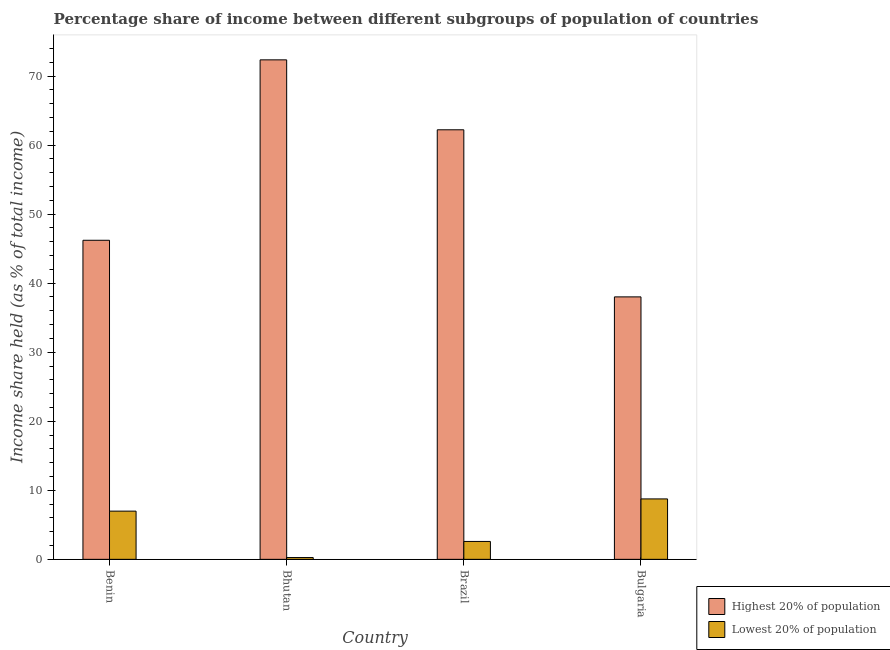Are the number of bars on each tick of the X-axis equal?
Provide a short and direct response. Yes. How many bars are there on the 1st tick from the left?
Ensure brevity in your answer.  2. How many bars are there on the 1st tick from the right?
Ensure brevity in your answer.  2. What is the income share held by lowest 20% of the population in Benin?
Keep it short and to the point. 6.98. Across all countries, what is the maximum income share held by highest 20% of the population?
Give a very brief answer. 72.34. Across all countries, what is the minimum income share held by lowest 20% of the population?
Offer a very short reply. 0.26. In which country was the income share held by highest 20% of the population maximum?
Provide a succinct answer. Bhutan. In which country was the income share held by lowest 20% of the population minimum?
Your response must be concise. Bhutan. What is the total income share held by lowest 20% of the population in the graph?
Give a very brief answer. 18.58. What is the difference between the income share held by highest 20% of the population in Bhutan and that in Brazil?
Provide a succinct answer. 10.13. What is the difference between the income share held by lowest 20% of the population in Bulgaria and the income share held by highest 20% of the population in Brazil?
Provide a short and direct response. -53.46. What is the average income share held by highest 20% of the population per country?
Your answer should be compact. 54.69. What is the difference between the income share held by lowest 20% of the population and income share held by highest 20% of the population in Bhutan?
Your answer should be very brief. -72.08. In how many countries, is the income share held by highest 20% of the population greater than 62 %?
Make the answer very short. 2. What is the ratio of the income share held by lowest 20% of the population in Brazil to that in Bulgaria?
Provide a succinct answer. 0.3. Is the difference between the income share held by lowest 20% of the population in Bhutan and Brazil greater than the difference between the income share held by highest 20% of the population in Bhutan and Brazil?
Keep it short and to the point. No. What is the difference between the highest and the second highest income share held by highest 20% of the population?
Your answer should be compact. 10.13. What is the difference between the highest and the lowest income share held by highest 20% of the population?
Your answer should be compact. 34.33. Is the sum of the income share held by lowest 20% of the population in Benin and Brazil greater than the maximum income share held by highest 20% of the population across all countries?
Ensure brevity in your answer.  No. What does the 2nd bar from the left in Bulgaria represents?
Provide a succinct answer. Lowest 20% of population. What does the 1st bar from the right in Bulgaria represents?
Provide a short and direct response. Lowest 20% of population. How many bars are there?
Provide a succinct answer. 8. Are all the bars in the graph horizontal?
Offer a very short reply. No. How many countries are there in the graph?
Offer a terse response. 4. What is the difference between two consecutive major ticks on the Y-axis?
Make the answer very short. 10. Does the graph contain any zero values?
Your answer should be compact. No. Does the graph contain grids?
Give a very brief answer. No. Where does the legend appear in the graph?
Your response must be concise. Bottom right. How many legend labels are there?
Offer a terse response. 2. What is the title of the graph?
Your answer should be very brief. Percentage share of income between different subgroups of population of countries. Does "Rural" appear as one of the legend labels in the graph?
Your answer should be very brief. No. What is the label or title of the X-axis?
Your response must be concise. Country. What is the label or title of the Y-axis?
Keep it short and to the point. Income share held (as % of total income). What is the Income share held (as % of total income) in Highest 20% of population in Benin?
Provide a succinct answer. 46.21. What is the Income share held (as % of total income) of Lowest 20% of population in Benin?
Your answer should be very brief. 6.98. What is the Income share held (as % of total income) of Highest 20% of population in Bhutan?
Your answer should be very brief. 72.34. What is the Income share held (as % of total income) in Lowest 20% of population in Bhutan?
Offer a very short reply. 0.26. What is the Income share held (as % of total income) in Highest 20% of population in Brazil?
Your response must be concise. 62.21. What is the Income share held (as % of total income) of Lowest 20% of population in Brazil?
Provide a short and direct response. 2.59. What is the Income share held (as % of total income) in Highest 20% of population in Bulgaria?
Keep it short and to the point. 38.01. What is the Income share held (as % of total income) of Lowest 20% of population in Bulgaria?
Offer a terse response. 8.75. Across all countries, what is the maximum Income share held (as % of total income) of Highest 20% of population?
Offer a terse response. 72.34. Across all countries, what is the maximum Income share held (as % of total income) of Lowest 20% of population?
Ensure brevity in your answer.  8.75. Across all countries, what is the minimum Income share held (as % of total income) in Highest 20% of population?
Your answer should be very brief. 38.01. Across all countries, what is the minimum Income share held (as % of total income) in Lowest 20% of population?
Your answer should be very brief. 0.26. What is the total Income share held (as % of total income) in Highest 20% of population in the graph?
Provide a short and direct response. 218.77. What is the total Income share held (as % of total income) of Lowest 20% of population in the graph?
Give a very brief answer. 18.58. What is the difference between the Income share held (as % of total income) in Highest 20% of population in Benin and that in Bhutan?
Provide a short and direct response. -26.13. What is the difference between the Income share held (as % of total income) in Lowest 20% of population in Benin and that in Bhutan?
Your answer should be very brief. 6.72. What is the difference between the Income share held (as % of total income) in Highest 20% of population in Benin and that in Brazil?
Ensure brevity in your answer.  -16. What is the difference between the Income share held (as % of total income) of Lowest 20% of population in Benin and that in Brazil?
Your answer should be very brief. 4.39. What is the difference between the Income share held (as % of total income) in Lowest 20% of population in Benin and that in Bulgaria?
Ensure brevity in your answer.  -1.77. What is the difference between the Income share held (as % of total income) of Highest 20% of population in Bhutan and that in Brazil?
Your answer should be very brief. 10.13. What is the difference between the Income share held (as % of total income) of Lowest 20% of population in Bhutan and that in Brazil?
Keep it short and to the point. -2.33. What is the difference between the Income share held (as % of total income) in Highest 20% of population in Bhutan and that in Bulgaria?
Make the answer very short. 34.33. What is the difference between the Income share held (as % of total income) of Lowest 20% of population in Bhutan and that in Bulgaria?
Provide a short and direct response. -8.49. What is the difference between the Income share held (as % of total income) in Highest 20% of population in Brazil and that in Bulgaria?
Provide a short and direct response. 24.2. What is the difference between the Income share held (as % of total income) of Lowest 20% of population in Brazil and that in Bulgaria?
Make the answer very short. -6.16. What is the difference between the Income share held (as % of total income) of Highest 20% of population in Benin and the Income share held (as % of total income) of Lowest 20% of population in Bhutan?
Your response must be concise. 45.95. What is the difference between the Income share held (as % of total income) in Highest 20% of population in Benin and the Income share held (as % of total income) in Lowest 20% of population in Brazil?
Provide a succinct answer. 43.62. What is the difference between the Income share held (as % of total income) in Highest 20% of population in Benin and the Income share held (as % of total income) in Lowest 20% of population in Bulgaria?
Make the answer very short. 37.46. What is the difference between the Income share held (as % of total income) in Highest 20% of population in Bhutan and the Income share held (as % of total income) in Lowest 20% of population in Brazil?
Offer a very short reply. 69.75. What is the difference between the Income share held (as % of total income) of Highest 20% of population in Bhutan and the Income share held (as % of total income) of Lowest 20% of population in Bulgaria?
Provide a short and direct response. 63.59. What is the difference between the Income share held (as % of total income) in Highest 20% of population in Brazil and the Income share held (as % of total income) in Lowest 20% of population in Bulgaria?
Your answer should be compact. 53.46. What is the average Income share held (as % of total income) of Highest 20% of population per country?
Offer a terse response. 54.69. What is the average Income share held (as % of total income) of Lowest 20% of population per country?
Give a very brief answer. 4.64. What is the difference between the Income share held (as % of total income) in Highest 20% of population and Income share held (as % of total income) in Lowest 20% of population in Benin?
Provide a short and direct response. 39.23. What is the difference between the Income share held (as % of total income) of Highest 20% of population and Income share held (as % of total income) of Lowest 20% of population in Bhutan?
Make the answer very short. 72.08. What is the difference between the Income share held (as % of total income) of Highest 20% of population and Income share held (as % of total income) of Lowest 20% of population in Brazil?
Make the answer very short. 59.62. What is the difference between the Income share held (as % of total income) in Highest 20% of population and Income share held (as % of total income) in Lowest 20% of population in Bulgaria?
Your answer should be very brief. 29.26. What is the ratio of the Income share held (as % of total income) of Highest 20% of population in Benin to that in Bhutan?
Your response must be concise. 0.64. What is the ratio of the Income share held (as % of total income) of Lowest 20% of population in Benin to that in Bhutan?
Give a very brief answer. 26.85. What is the ratio of the Income share held (as % of total income) of Highest 20% of population in Benin to that in Brazil?
Your response must be concise. 0.74. What is the ratio of the Income share held (as % of total income) of Lowest 20% of population in Benin to that in Brazil?
Your response must be concise. 2.69. What is the ratio of the Income share held (as % of total income) of Highest 20% of population in Benin to that in Bulgaria?
Your answer should be compact. 1.22. What is the ratio of the Income share held (as % of total income) in Lowest 20% of population in Benin to that in Bulgaria?
Your response must be concise. 0.8. What is the ratio of the Income share held (as % of total income) in Highest 20% of population in Bhutan to that in Brazil?
Your answer should be very brief. 1.16. What is the ratio of the Income share held (as % of total income) in Lowest 20% of population in Bhutan to that in Brazil?
Provide a short and direct response. 0.1. What is the ratio of the Income share held (as % of total income) of Highest 20% of population in Bhutan to that in Bulgaria?
Offer a very short reply. 1.9. What is the ratio of the Income share held (as % of total income) in Lowest 20% of population in Bhutan to that in Bulgaria?
Make the answer very short. 0.03. What is the ratio of the Income share held (as % of total income) in Highest 20% of population in Brazil to that in Bulgaria?
Your answer should be compact. 1.64. What is the ratio of the Income share held (as % of total income) in Lowest 20% of population in Brazil to that in Bulgaria?
Offer a terse response. 0.3. What is the difference between the highest and the second highest Income share held (as % of total income) in Highest 20% of population?
Provide a short and direct response. 10.13. What is the difference between the highest and the second highest Income share held (as % of total income) of Lowest 20% of population?
Provide a short and direct response. 1.77. What is the difference between the highest and the lowest Income share held (as % of total income) of Highest 20% of population?
Make the answer very short. 34.33. What is the difference between the highest and the lowest Income share held (as % of total income) of Lowest 20% of population?
Your response must be concise. 8.49. 